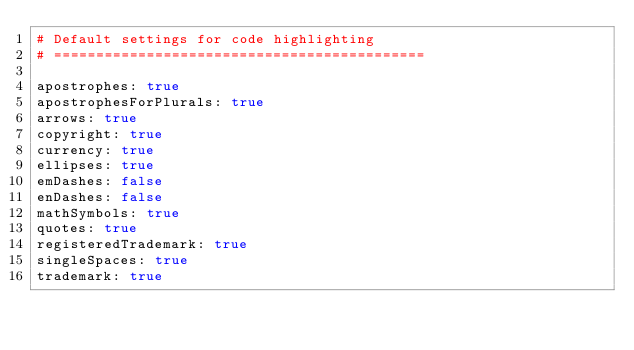Convert code to text. <code><loc_0><loc_0><loc_500><loc_500><_YAML_># Default settings for code highlighting
# ============================================

apostrophes: true
apostrophesForPlurals: true
arrows: true
copyright: true
currency: true
ellipses: true
emDashes: false
enDashes: false
mathSymbols: true
quotes: true
registeredTrademark: true
singleSpaces: true
trademark: true
</code> 